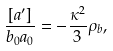Convert formula to latex. <formula><loc_0><loc_0><loc_500><loc_500>\frac { [ a ^ { \prime } ] } { b _ { 0 } a _ { 0 } } = - \frac { \kappa ^ { 2 } } { 3 } \rho _ { b } ,</formula> 